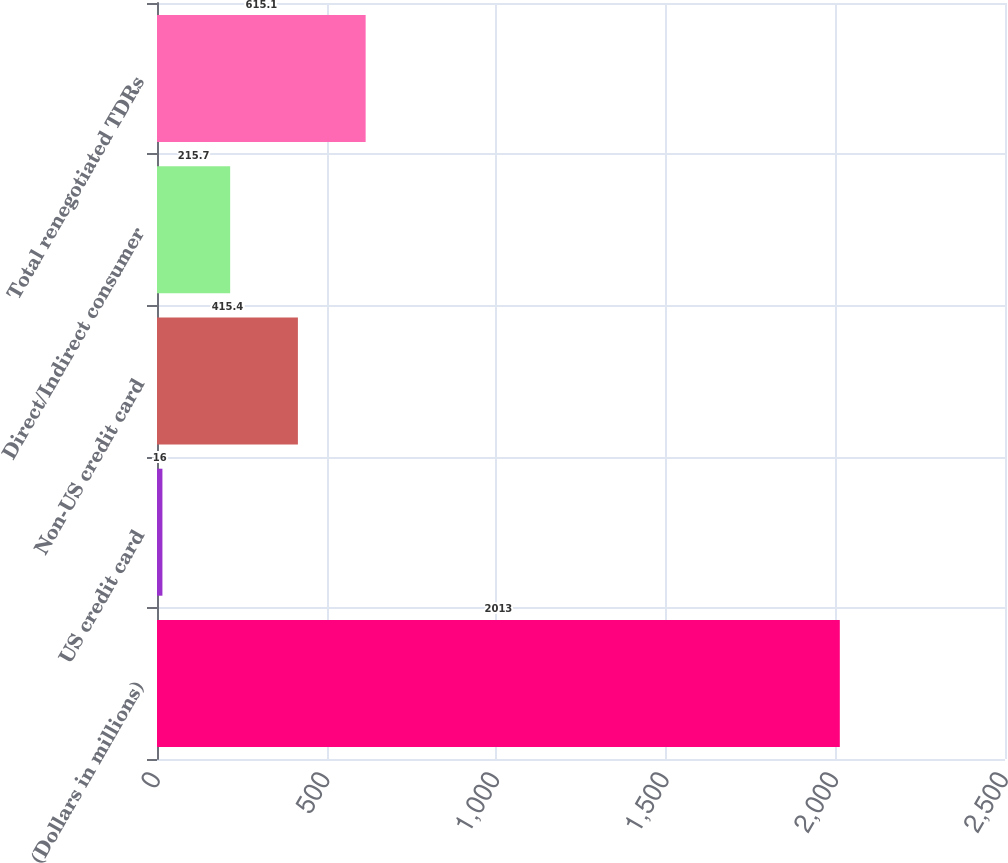<chart> <loc_0><loc_0><loc_500><loc_500><bar_chart><fcel>(Dollars in millions)<fcel>US credit card<fcel>Non-US credit card<fcel>Direct/Indirect consumer<fcel>Total renegotiated TDRs<nl><fcel>2013<fcel>16<fcel>415.4<fcel>215.7<fcel>615.1<nl></chart> 